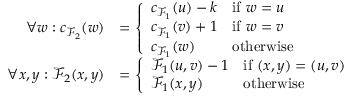<formula> <loc_0><loc_0><loc_500><loc_500>\begin{array} { r l } { \forall w \colon c _ { \mathcal { F } _ { 2 } } ( w ) } & { = \left \{ \begin{array} { l l } { c _ { \mathcal { F } _ { 1 } } ( u ) - k } & { i f w = u } \\ { c _ { \mathcal { F } _ { 1 } } ( v ) + 1 } & { i f w = v } \\ { c _ { \mathcal { F } _ { 1 } } ( w ) } & { o t h e r w i s e } \end{array} } \\ { \forall x , y \colon \mathcal { F } _ { 2 } ( x , y ) } & { = \left \{ \begin{array} { l l } { \mathcal { F } _ { 1 } ( u , v ) - 1 } & { i f ( x , y ) = ( u , v ) } \\ { \mathcal { F } _ { 1 } ( x , y ) } & { o t h e r w i s e } \end{array} } \end{array}</formula> 